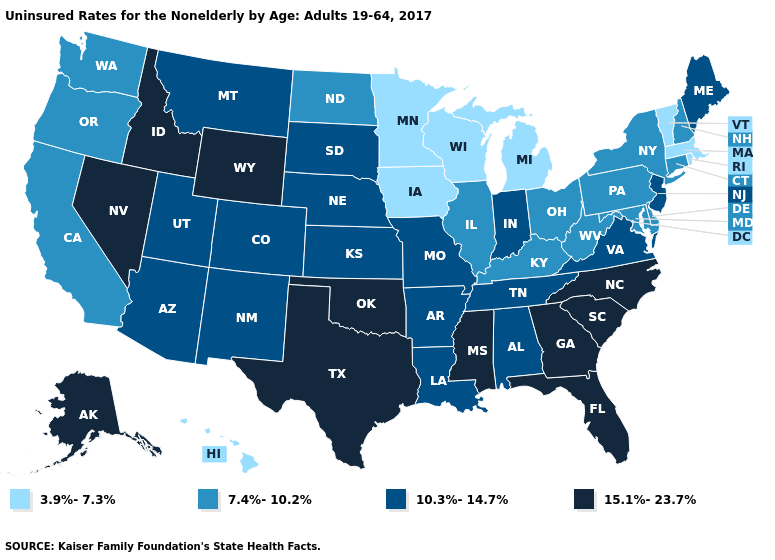What is the value of Vermont?
Short answer required. 3.9%-7.3%. Name the states that have a value in the range 15.1%-23.7%?
Give a very brief answer. Alaska, Florida, Georgia, Idaho, Mississippi, Nevada, North Carolina, Oklahoma, South Carolina, Texas, Wyoming. Name the states that have a value in the range 10.3%-14.7%?
Write a very short answer. Alabama, Arizona, Arkansas, Colorado, Indiana, Kansas, Louisiana, Maine, Missouri, Montana, Nebraska, New Jersey, New Mexico, South Dakota, Tennessee, Utah, Virginia. Does the map have missing data?
Quick response, please. No. Does Hawaii have a lower value than Mississippi?
Be succinct. Yes. Name the states that have a value in the range 3.9%-7.3%?
Answer briefly. Hawaii, Iowa, Massachusetts, Michigan, Minnesota, Rhode Island, Vermont, Wisconsin. Name the states that have a value in the range 15.1%-23.7%?
Concise answer only. Alaska, Florida, Georgia, Idaho, Mississippi, Nevada, North Carolina, Oklahoma, South Carolina, Texas, Wyoming. Name the states that have a value in the range 15.1%-23.7%?
Concise answer only. Alaska, Florida, Georgia, Idaho, Mississippi, Nevada, North Carolina, Oklahoma, South Carolina, Texas, Wyoming. Name the states that have a value in the range 3.9%-7.3%?
Concise answer only. Hawaii, Iowa, Massachusetts, Michigan, Minnesota, Rhode Island, Vermont, Wisconsin. What is the highest value in the USA?
Short answer required. 15.1%-23.7%. Does Delaware have a lower value than Rhode Island?
Quick response, please. No. Does Maryland have the same value as South Carolina?
Be succinct. No. Does Hawaii have the lowest value in the USA?
Write a very short answer. Yes. What is the value of Rhode Island?
Keep it brief. 3.9%-7.3%. What is the lowest value in states that border Missouri?
Concise answer only. 3.9%-7.3%. 